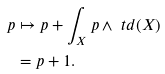Convert formula to latex. <formula><loc_0><loc_0><loc_500><loc_500>p & \mapsto p + \int _ { X } p \wedge \ t d ( X ) \\ & = p + 1 .</formula> 